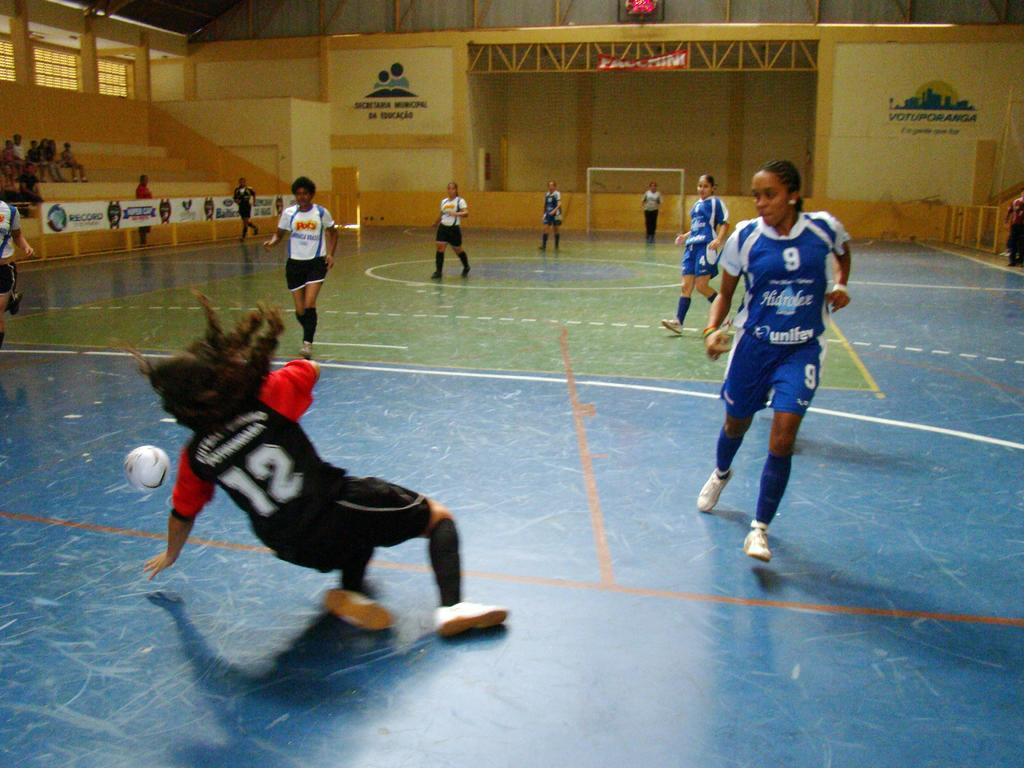<image>
Relay a brief, clear account of the picture shown. Athletes playing a sport indoors and player number 12 is falling down. 